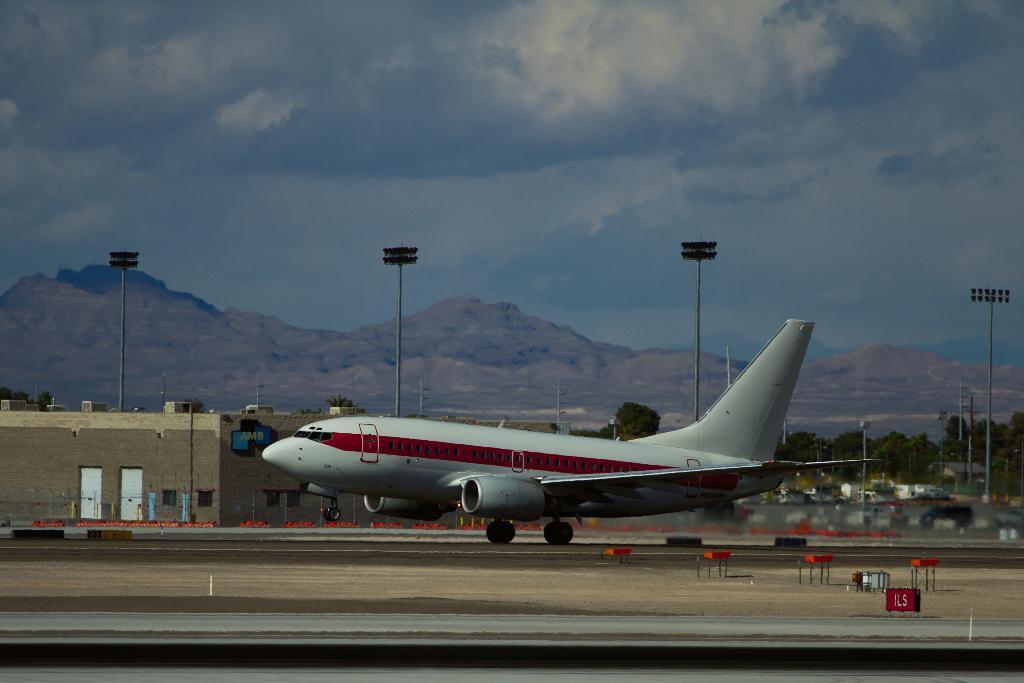Could you give a brief overview of what you see in this image? In the picture we can see a flight on the runway, which is white in color and behind it, we can see a house with two doors and besides, we can see the poles with lights and trees and in the background we can see the hills and the sky with clouds. 